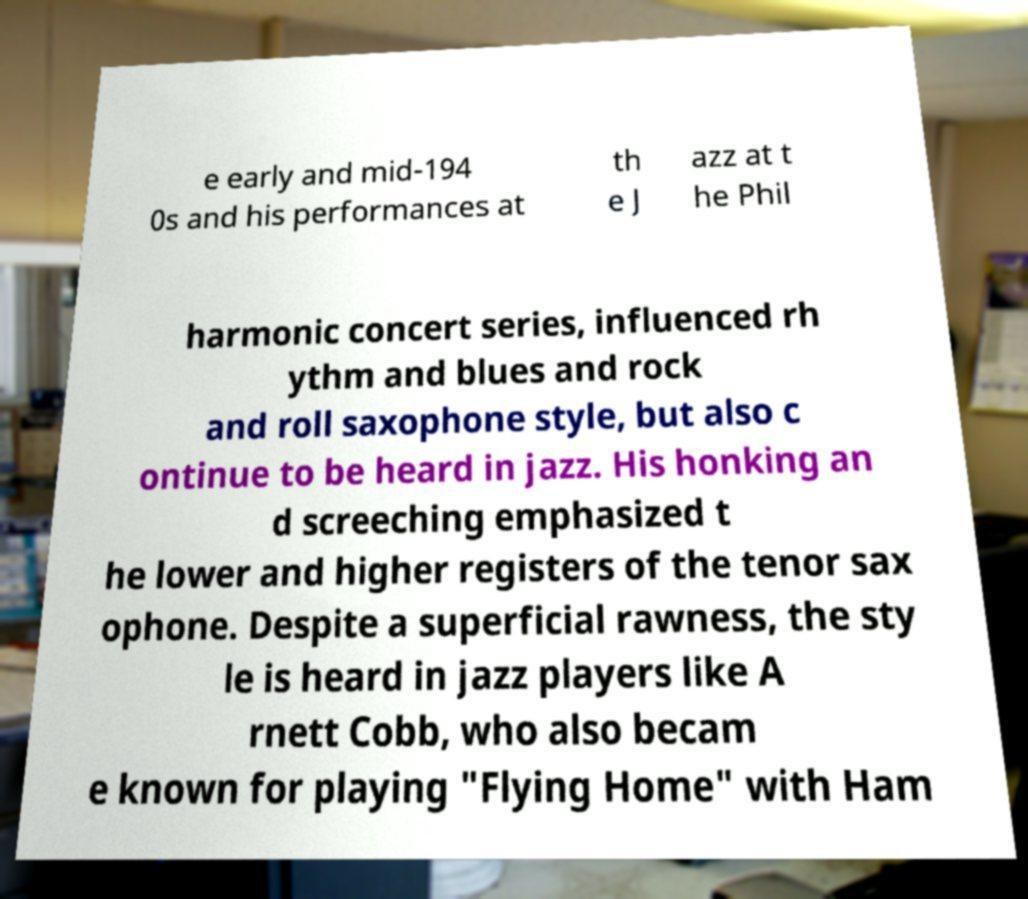I need the written content from this picture converted into text. Can you do that? e early and mid-194 0s and his performances at th e J azz at t he Phil harmonic concert series, influenced rh ythm and blues and rock and roll saxophone style, but also c ontinue to be heard in jazz. His honking an d screeching emphasized t he lower and higher registers of the tenor sax ophone. Despite a superficial rawness, the sty le is heard in jazz players like A rnett Cobb, who also becam e known for playing "Flying Home" with Ham 